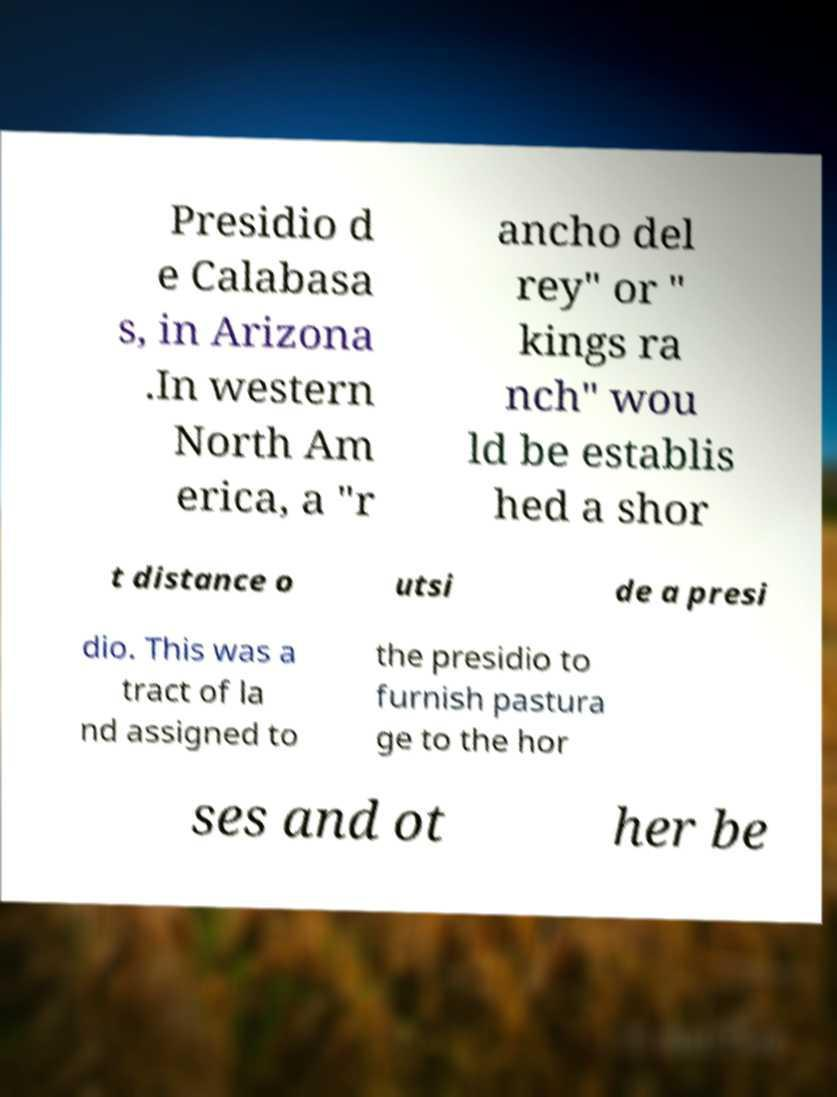Could you extract and type out the text from this image? Presidio d e Calabasa s, in Arizona .In western North Am erica, a "r ancho del rey" or " kings ra nch" wou ld be establis hed a shor t distance o utsi de a presi dio. This was a tract of la nd assigned to the presidio to furnish pastura ge to the hor ses and ot her be 